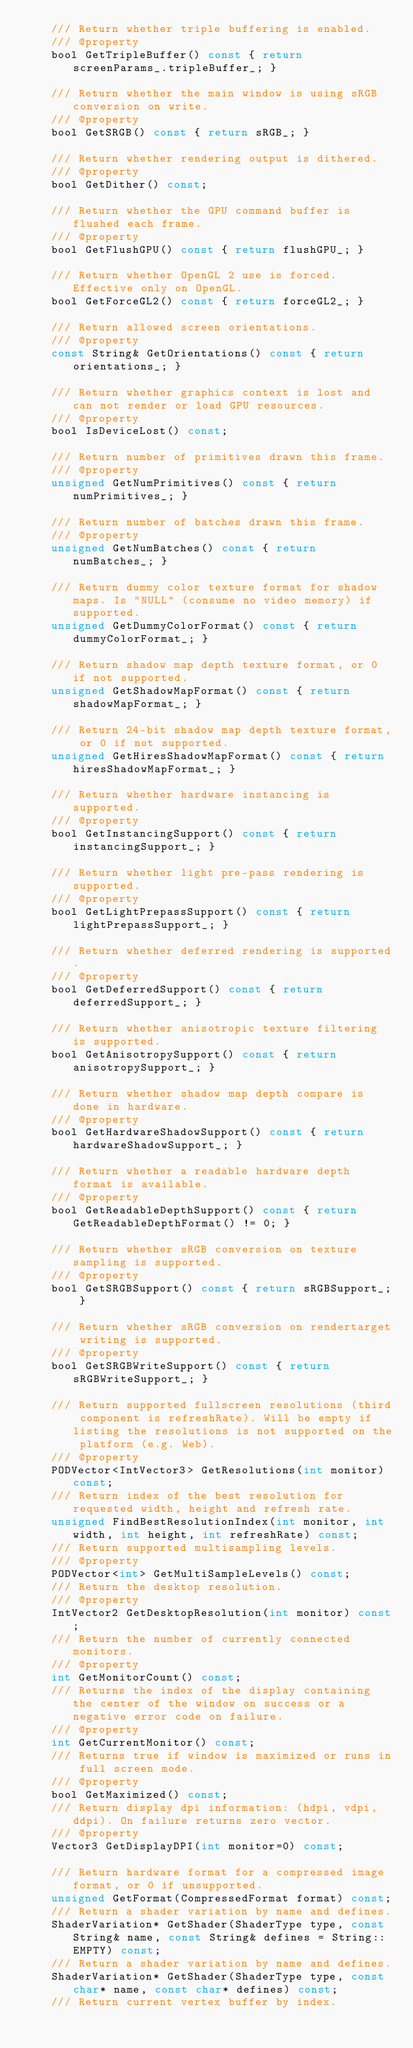Convert code to text. <code><loc_0><loc_0><loc_500><loc_500><_C_>    /// Return whether triple buffering is enabled.
    /// @property
    bool GetTripleBuffer() const { return screenParams_.tripleBuffer_; }

    /// Return whether the main window is using sRGB conversion on write.
    /// @property
    bool GetSRGB() const { return sRGB_; }

    /// Return whether rendering output is dithered.
    /// @property
    bool GetDither() const;

    /// Return whether the GPU command buffer is flushed each frame.
    /// @property
    bool GetFlushGPU() const { return flushGPU_; }

    /// Return whether OpenGL 2 use is forced. Effective only on OpenGL.
    bool GetForceGL2() const { return forceGL2_; }

    /// Return allowed screen orientations.
    /// @property
    const String& GetOrientations() const { return orientations_; }

    /// Return whether graphics context is lost and can not render or load GPU resources.
    /// @property
    bool IsDeviceLost() const;

    /// Return number of primitives drawn this frame.
    /// @property
    unsigned GetNumPrimitives() const { return numPrimitives_; }

    /// Return number of batches drawn this frame.
    /// @property
    unsigned GetNumBatches() const { return numBatches_; }

    /// Return dummy color texture format for shadow maps. Is "NULL" (consume no video memory) if supported.
    unsigned GetDummyColorFormat() const { return dummyColorFormat_; }

    /// Return shadow map depth texture format, or 0 if not supported.
    unsigned GetShadowMapFormat() const { return shadowMapFormat_; }

    /// Return 24-bit shadow map depth texture format, or 0 if not supported.
    unsigned GetHiresShadowMapFormat() const { return hiresShadowMapFormat_; }

    /// Return whether hardware instancing is supported.
    /// @property
    bool GetInstancingSupport() const { return instancingSupport_; }

    /// Return whether light pre-pass rendering is supported.
    /// @property
    bool GetLightPrepassSupport() const { return lightPrepassSupport_; }

    /// Return whether deferred rendering is supported.
    /// @property
    bool GetDeferredSupport() const { return deferredSupport_; }

    /// Return whether anisotropic texture filtering is supported.
    bool GetAnisotropySupport() const { return anisotropySupport_; }

    /// Return whether shadow map depth compare is done in hardware.
    /// @property
    bool GetHardwareShadowSupport() const { return hardwareShadowSupport_; }

    /// Return whether a readable hardware depth format is available.
    /// @property
    bool GetReadableDepthSupport() const { return GetReadableDepthFormat() != 0; }

    /// Return whether sRGB conversion on texture sampling is supported.
    /// @property
    bool GetSRGBSupport() const { return sRGBSupport_; }

    /// Return whether sRGB conversion on rendertarget writing is supported.
    /// @property
    bool GetSRGBWriteSupport() const { return sRGBWriteSupport_; }

    /// Return supported fullscreen resolutions (third component is refreshRate). Will be empty if listing the resolutions is not supported on the platform (e.g. Web).
    /// @property
    PODVector<IntVector3> GetResolutions(int monitor) const;
    /// Return index of the best resolution for requested width, height and refresh rate.
    unsigned FindBestResolutionIndex(int monitor, int width, int height, int refreshRate) const;
    /// Return supported multisampling levels.
    /// @property
    PODVector<int> GetMultiSampleLevels() const;
    /// Return the desktop resolution.
    /// @property
    IntVector2 GetDesktopResolution(int monitor) const;
    /// Return the number of currently connected monitors.
    /// @property
    int GetMonitorCount() const;
    /// Returns the index of the display containing the center of the window on success or a negative error code on failure.
    /// @property
    int GetCurrentMonitor() const;
    /// Returns true if window is maximized or runs in full screen mode.
    /// @property
    bool GetMaximized() const;
    /// Return display dpi information: (hdpi, vdpi, ddpi). On failure returns zero vector.
    /// @property
    Vector3 GetDisplayDPI(int monitor=0) const;

    /// Return hardware format for a compressed image format, or 0 if unsupported.
    unsigned GetFormat(CompressedFormat format) const;
    /// Return a shader variation by name and defines.
    ShaderVariation* GetShader(ShaderType type, const String& name, const String& defines = String::EMPTY) const;
    /// Return a shader variation by name and defines.
    ShaderVariation* GetShader(ShaderType type, const char* name, const char* defines) const;
    /// Return current vertex buffer by index.</code> 